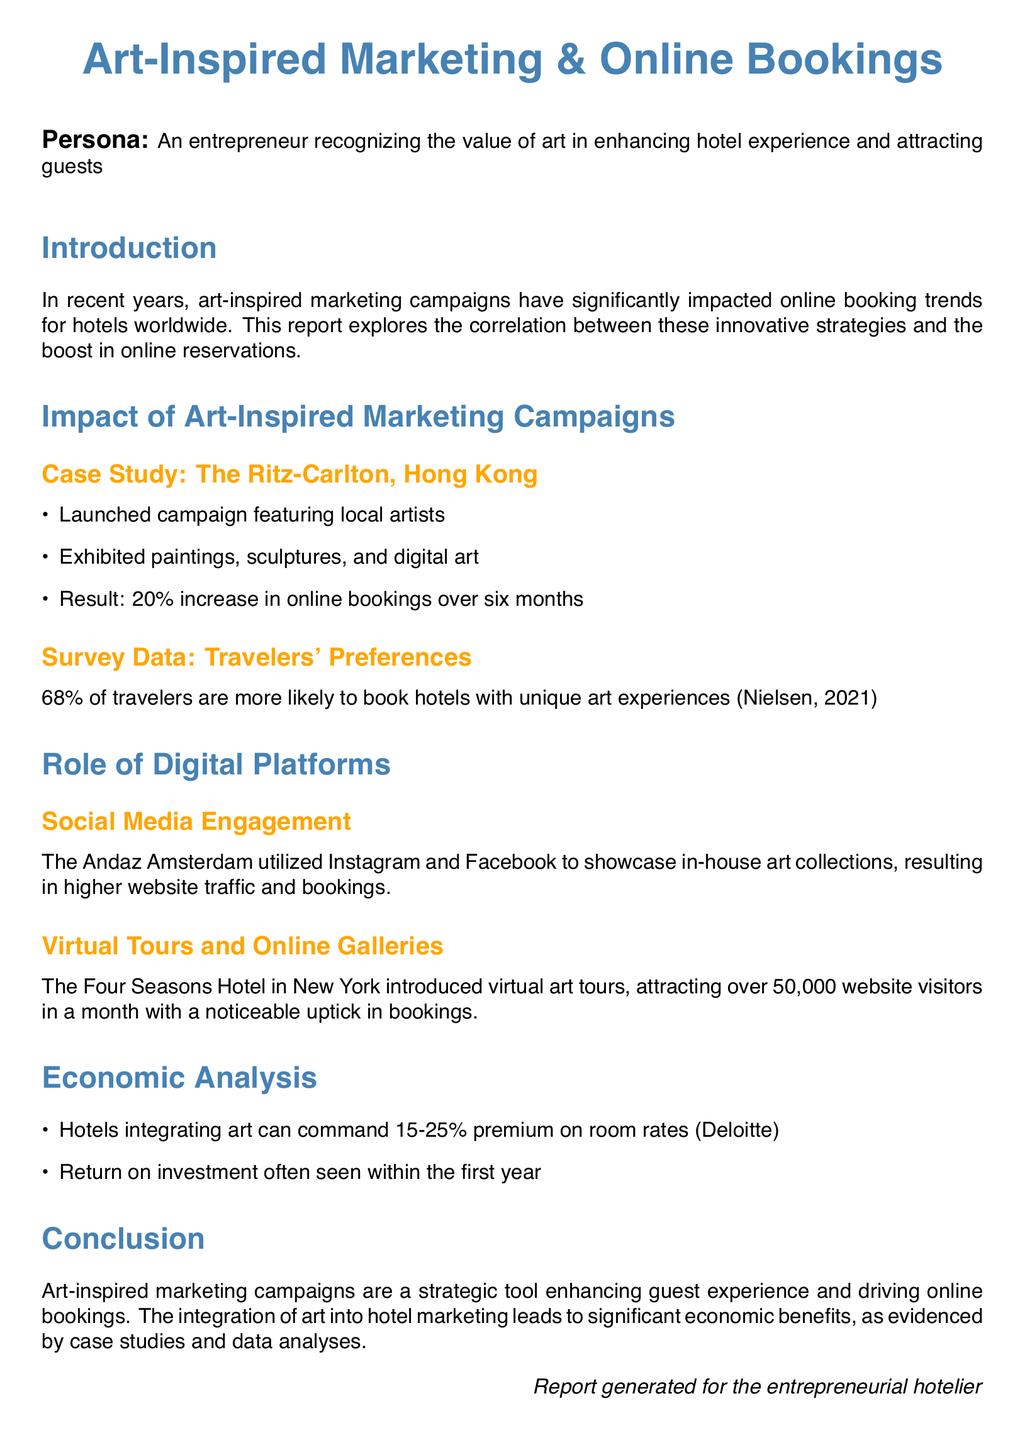What was the percentage increase in online bookings at The Ritz-Carlton, Hong Kong? The document states that there was a 20% increase in online bookings as a result of the campaign.
Answer: 20% What percentage of travelers prefer hotels with unique art experiences? According to the survey data mentioned, 68% of travelers are more likely to book such hotels.
Answer: 68% What type of social media did The Andaz Amsterdam use for its marketing? The report specifies that Instagram and Facebook were the platforms utilized for showcasing art collections.
Answer: Instagram and Facebook How many website visitors did The Four Seasons Hotel in New York attract with virtual art tours? The document mentions that the hotel attracted over 50,000 visitors in a month through these tours.
Answer: 50,000 What premium can hotels integrating art command on room rates? The economic analysis suggests that hotels can command a 15-25% premium on room rates with art integration.
Answer: 15-25% What is one benefit of art-inspired marketing campaigns mentioned in the conclusion? The conclusion highlights that these campaigns enhance guest experience and drive online bookings, among other benefits.
Answer: Enhance guest experience What year often sees a return on investment for art-integrated hotels? The document notes that hotels typically see a return on investment within the first year.
Answer: First year Who generated this report? At the end of the document, it states that the report was generated for the entrepreneurial hotelier.
Answer: Entrepreneurial hotelier 